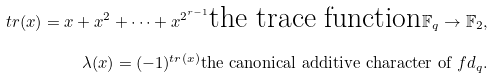Convert formula to latex. <formula><loc_0><loc_0><loc_500><loc_500>t r ( x ) = x + x ^ { 2 } + \cdots + x ^ { 2 ^ { r - 1 } } \text {the trace function} \mathbb { F } _ { q } \rightarrow \mathbb { F } _ { 2 } , \\ \lambda ( x ) = ( - 1 ) ^ { t r ( x ) } \text {the canonical additive character of} \ f d _ { q } .</formula> 